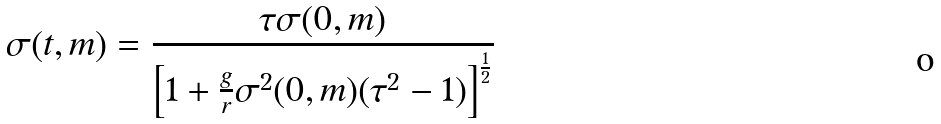<formula> <loc_0><loc_0><loc_500><loc_500>\sigma ( t , m ) = \frac { \tau \sigma ( 0 , m ) } { \left [ 1 + \frac { g } { r } \sigma ^ { 2 } ( 0 , m ) ( \tau ^ { 2 } - 1 ) \right ] ^ { \frac { 1 } { 2 } } }</formula> 